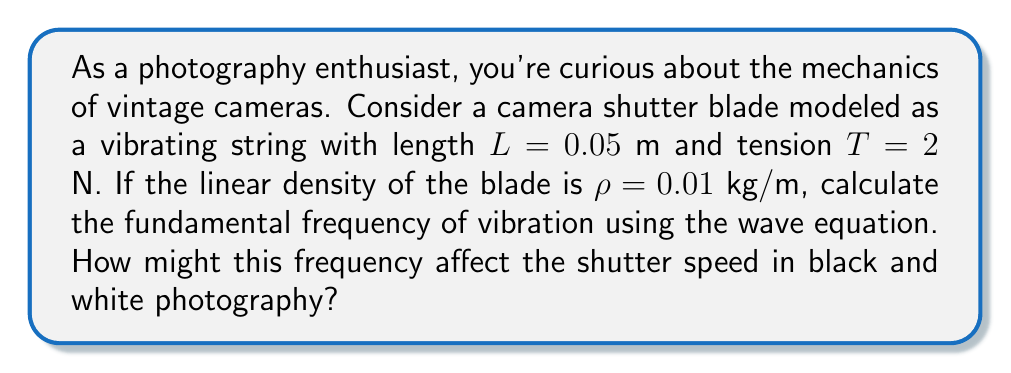Show me your answer to this math problem. To solve this problem, we'll use the wave equation for a vibrating string:

1) The wave equation for a vibrating string is:

   $$\frac{\partial^2 y}{\partial t^2} = v^2 \frac{\partial^2 y}{\partial x^2}$$

   where $v$ is the wave speed.

2) The wave speed $v$ is given by:

   $$v = \sqrt{\frac{T}{\rho}}$$

3) Substituting the given values:

   $$v = \sqrt{\frac{2 \text{ N}}{0.01 \text{ kg/m}}} = \sqrt{200} \approx 14.14 \text{ m/s}$$

4) The fundamental frequency $f$ of a vibrating string is related to its length $L$ and wave speed $v$ by:

   $$f = \frac{v}{2L}$$

5) Substituting our values:

   $$f = \frac{14.14 \text{ m/s}}{2(0.05 \text{ m})} = 141.4 \text{ Hz}$$

6) This frequency of about 141.4 Hz means the shutter blade vibrates approximately 141 times per second.

7) In black and white photography, this high frequency allows for very fast shutter speeds, which can be crucial for capturing sharp images of moving subjects or in low light conditions.
Answer: 141.4 Hz 